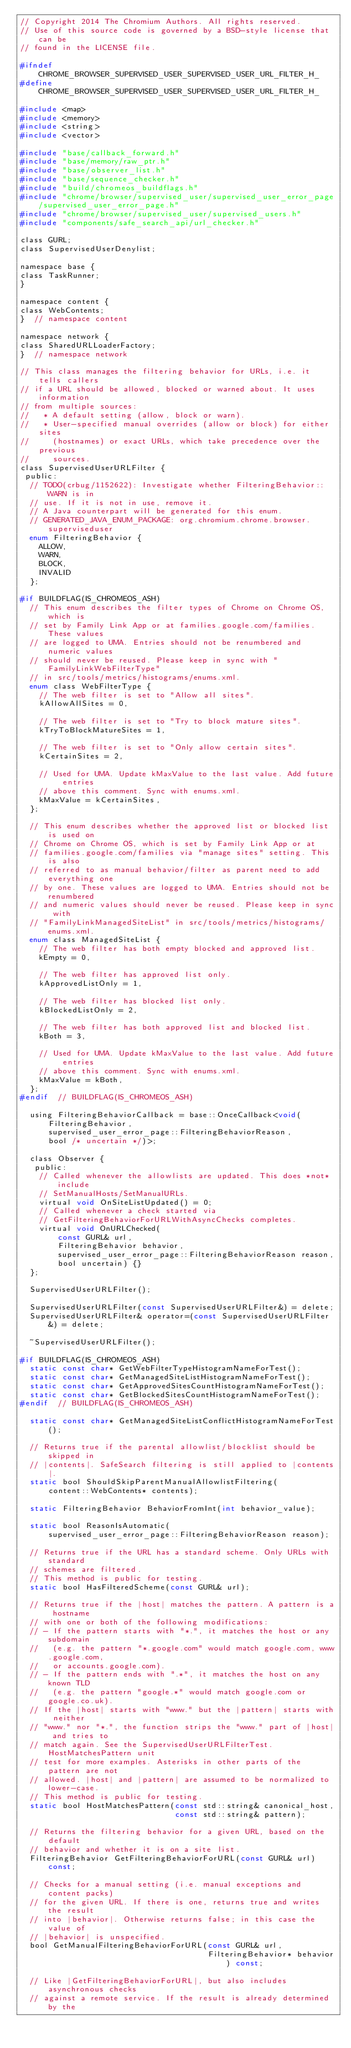<code> <loc_0><loc_0><loc_500><loc_500><_C_>// Copyright 2014 The Chromium Authors. All rights reserved.
// Use of this source code is governed by a BSD-style license that can be
// found in the LICENSE file.

#ifndef CHROME_BROWSER_SUPERVISED_USER_SUPERVISED_USER_URL_FILTER_H_
#define CHROME_BROWSER_SUPERVISED_USER_SUPERVISED_USER_URL_FILTER_H_

#include <map>
#include <memory>
#include <string>
#include <vector>

#include "base/callback_forward.h"
#include "base/memory/raw_ptr.h"
#include "base/observer_list.h"
#include "base/sequence_checker.h"
#include "build/chromeos_buildflags.h"
#include "chrome/browser/supervised_user/supervised_user_error_page/supervised_user_error_page.h"
#include "chrome/browser/supervised_user/supervised_users.h"
#include "components/safe_search_api/url_checker.h"

class GURL;
class SupervisedUserDenylist;

namespace base {
class TaskRunner;
}

namespace content {
class WebContents;
}  // namespace content

namespace network {
class SharedURLLoaderFactory;
}  // namespace network

// This class manages the filtering behavior for URLs, i.e. it tells callers
// if a URL should be allowed, blocked or warned about. It uses information
// from multiple sources:
//   * A default setting (allow, block or warn).
//   * User-specified manual overrides (allow or block) for either sites
//     (hostnames) or exact URLs, which take precedence over the previous
//     sources.
class SupervisedUserURLFilter {
 public:
  // TODO(crbug/1152622): Investigate whether FilteringBehavior::WARN is in
  // use. If it is not in use, remove it.
  // A Java counterpart will be generated for this enum.
  // GENERATED_JAVA_ENUM_PACKAGE: org.chromium.chrome.browser.superviseduser
  enum FilteringBehavior {
    ALLOW,
    WARN,
    BLOCK,
    INVALID
  };

#if BUILDFLAG(IS_CHROMEOS_ASH)
  // This enum describes the filter types of Chrome on Chrome OS, which is
  // set by Family Link App or at families.google.com/families. These values
  // are logged to UMA. Entries should not be renumbered and numeric values
  // should never be reused. Please keep in sync with "FamilyLinkWebFilterType"
  // in src/tools/metrics/histograms/enums.xml.
  enum class WebFilterType {
    // The web filter is set to "Allow all sites".
    kAllowAllSites = 0,

    // The web filter is set to "Try to block mature sites".
    kTryToBlockMatureSites = 1,

    // The web filter is set to "Only allow certain sites".
    kCertainSites = 2,

    // Used for UMA. Update kMaxValue to the last value. Add future entries
    // above this comment. Sync with enums.xml.
    kMaxValue = kCertainSites,
  };

  // This enum describes whether the approved list or blocked list is used on
  // Chrome on Chrome OS, which is set by Family Link App or at
  // families.google.com/families via "manage sites" setting. This is also
  // referred to as manual behavior/filter as parent need to add everything one
  // by one. These values are logged to UMA. Entries should not be renumbered
  // and numeric values should never be reused. Please keep in sync with
  // "FamilyLinkManagedSiteList" in src/tools/metrics/histograms/enums.xml.
  enum class ManagedSiteList {
    // The web filter has both empty blocked and approved list.
    kEmpty = 0,

    // The web filter has approved list only.
    kApprovedListOnly = 1,

    // The web filter has blocked list only.
    kBlockedListOnly = 2,

    // The web filter has both approved list and blocked list.
    kBoth = 3,

    // Used for UMA. Update kMaxValue to the last value. Add future entries
    // above this comment. Sync with enums.xml.
    kMaxValue = kBoth,
  };
#endif  // BUILDFLAG(IS_CHROMEOS_ASH)

  using FilteringBehaviorCallback = base::OnceCallback<void(
      FilteringBehavior,
      supervised_user_error_page::FilteringBehaviorReason,
      bool /* uncertain */)>;

  class Observer {
   public:
    // Called whenever the allowlists are updated. This does *not* include
    // SetManualHosts/SetManualURLs.
    virtual void OnSiteListUpdated() = 0;
    // Called whenever a check started via
    // GetFilteringBehaviorForURLWithAsyncChecks completes.
    virtual void OnURLChecked(
        const GURL& url,
        FilteringBehavior behavior,
        supervised_user_error_page::FilteringBehaviorReason reason,
        bool uncertain) {}
  };

  SupervisedUserURLFilter();

  SupervisedUserURLFilter(const SupervisedUserURLFilter&) = delete;
  SupervisedUserURLFilter& operator=(const SupervisedUserURLFilter&) = delete;

  ~SupervisedUserURLFilter();

#if BUILDFLAG(IS_CHROMEOS_ASH)
  static const char* GetWebFilterTypeHistogramNameForTest();
  static const char* GetManagedSiteListHistogramNameForTest();
  static const char* GetApprovedSitesCountHistogramNameForTest();
  static const char* GetBlockedSitesCountHistogramNameForTest();
#endif  // BUILDFLAG(IS_CHROMEOS_ASH)

  static const char* GetManagedSiteListConflictHistogramNameForTest();

  // Returns true if the parental allowlist/blocklist should be skipped in
  // |contents|. SafeSearch filtering is still applied to |contents|.
  static bool ShouldSkipParentManualAllowlistFiltering(
      content::WebContents* contents);

  static FilteringBehavior BehaviorFromInt(int behavior_value);

  static bool ReasonIsAutomatic(
      supervised_user_error_page::FilteringBehaviorReason reason);

  // Returns true if the URL has a standard scheme. Only URLs with standard
  // schemes are filtered.
  // This method is public for testing.
  static bool HasFilteredScheme(const GURL& url);

  // Returns true if the |host| matches the pattern. A pattern is a hostname
  // with one or both of the following modifications:
  // - If the pattern starts with "*.", it matches the host or any subdomain
  //   (e.g. the pattern "*.google.com" would match google.com, www.google.com,
  //   or accounts.google.com).
  // - If the pattern ends with ".*", it matches the host on any known TLD
  //   (e.g. the pattern "google.*" would match google.com or google.co.uk).
  // If the |host| starts with "www." but the |pattern| starts with neither
  // "www." nor "*.", the function strips the "www." part of |host| and tries to
  // match again. See the SupervisedUserURLFilterTest.HostMatchesPattern unit
  // test for more examples. Asterisks in other parts of the pattern are not
  // allowed. |host| and |pattern| are assumed to be normalized to lower-case.
  // This method is public for testing.
  static bool HostMatchesPattern(const std::string& canonical_host,
                                 const std::string& pattern);

  // Returns the filtering behavior for a given URL, based on the default
  // behavior and whether it is on a site list.
  FilteringBehavior GetFilteringBehaviorForURL(const GURL& url) const;

  // Checks for a manual setting (i.e. manual exceptions and content packs)
  // for the given URL. If there is one, returns true and writes the result
  // into |behavior|. Otherwise returns false; in this case the value of
  // |behavior| is unspecified.
  bool GetManualFilteringBehaviorForURL(const GURL& url,
                                        FilteringBehavior* behavior) const;

  // Like |GetFilteringBehaviorForURL|, but also includes asynchronous checks
  // against a remote service. If the result is already determined by the</code> 